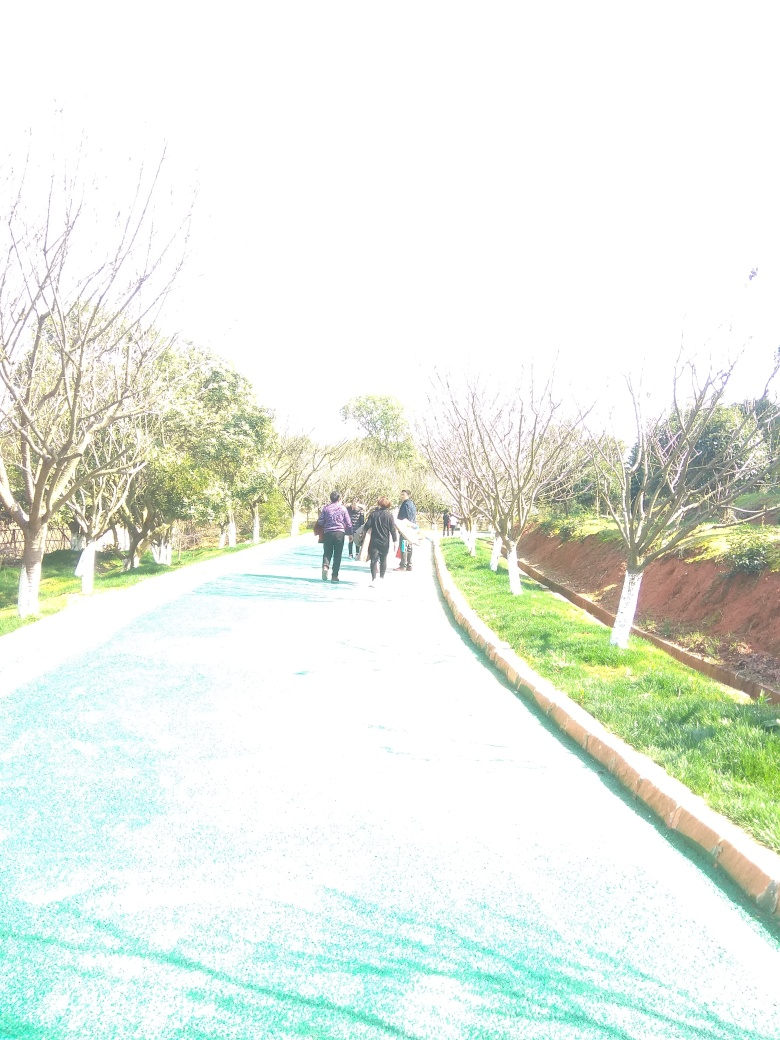Can you suggest a composition technique that might have enhanced this photo? To enhance the composition of an overexposed photo like this one, the photographer could have used the 'exposure compensation' feature on their camera to intentionally underexpose the shot slightly, which helps retain details in bright areas. Additionally, using angles or framing techniques to avoid direct sunlight, such as taking advantage of tree cover or waiting for a cloud to diffuse the light, would help balance the overall exposure of the scene. 